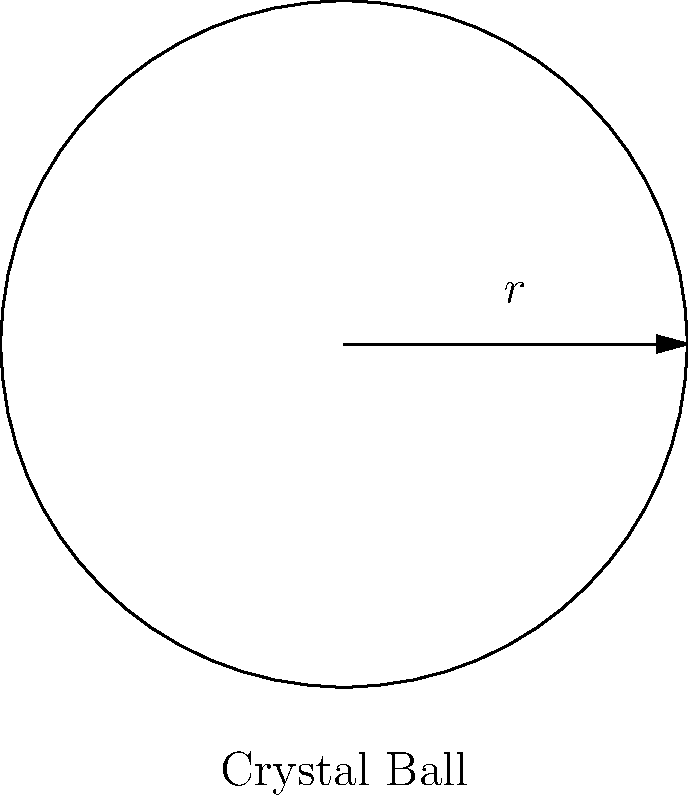As a mage specializing in divination, you've acquired a powerful crystal ball for scrying. The spherical crystal ball has a radius of 10 inches. To enhance its magical properties, you need to apply a thin layer of enchanted silver to its entire surface. If the cost of the enchanted silver is $5 per square inch, what is the total cost to cover the crystal ball's surface? Let's approach this step-by-step:

1) First, we need to calculate the surface area of the crystal ball. The formula for the surface area of a sphere is:

   $A = 4\pi r^2$

   Where $A$ is the surface area and $r$ is the radius.

2) We're given that the radius is 10 inches, so let's substitute this into our formula:

   $A = 4\pi (10)^2$

3) Let's calculate this:

   $A = 4\pi (100) = 400\pi$ square inches

4) Now that we have the surface area, we need to calculate the cost. We're told that the enchanted silver costs $5 per square inch.

5) To get the total cost, we multiply the surface area by the cost per square inch:

   Cost = $400\pi * \$5 = 2000\pi$ dollars

6) If we want to round this to the nearest dollar:

   Cost ≈ $6,283

Therefore, the total cost to cover the crystal ball's surface with enchanted silver is approximately $6,283.
Answer: $6,283 